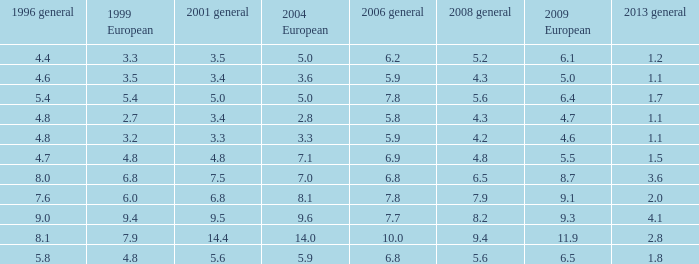4 in 1996 general? None. 